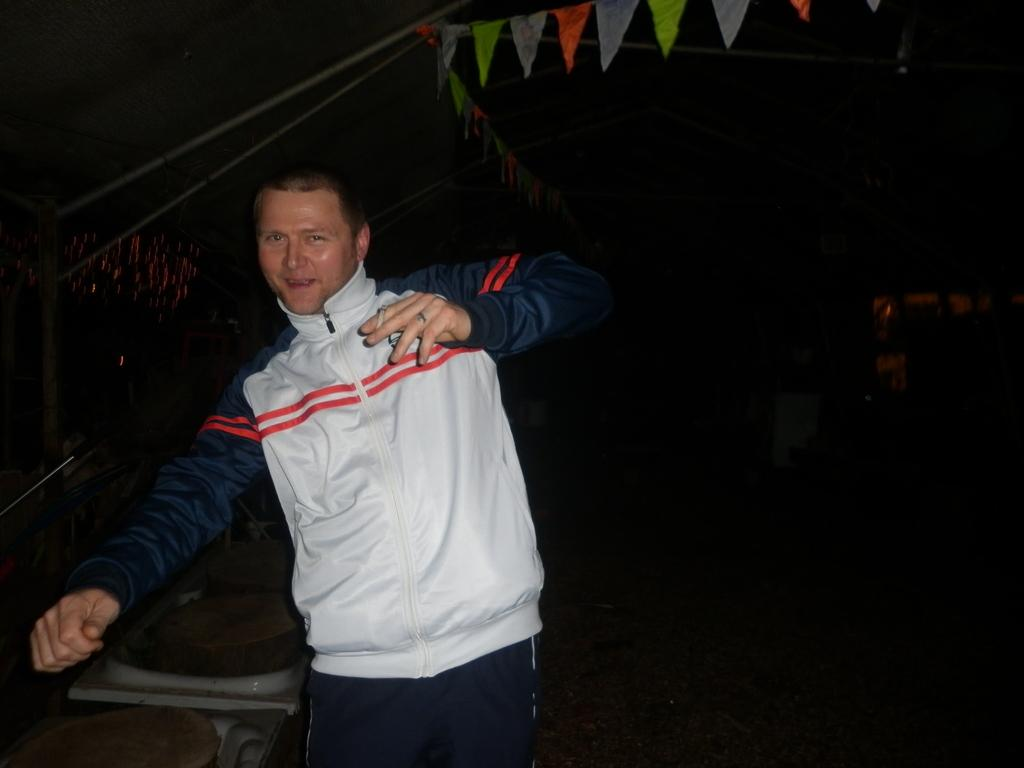What is the main subject of the image? There is a person standing in the image. What is the person holding in the image? The person is holding a cigarette. What objects can be seen at the top of the image? There are ropes visible at the top of the image. How many sisters are standing next to the person in the image? There is no mention of sisters in the image, so we cannot determine the number of sisters present. 